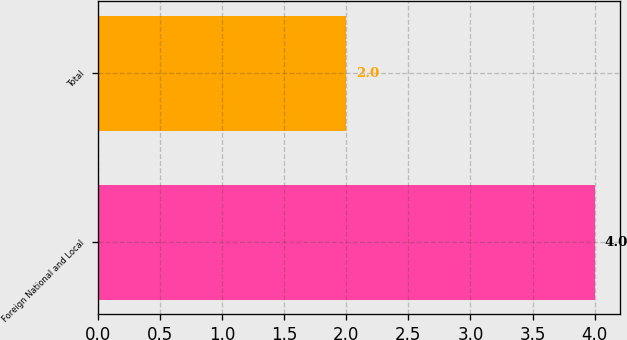<chart> <loc_0><loc_0><loc_500><loc_500><bar_chart><fcel>Foreign National and Local<fcel>Total<nl><fcel>4<fcel>2<nl></chart> 